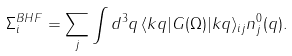<formula> <loc_0><loc_0><loc_500><loc_500>\Sigma _ { i } ^ { B H F } = \sum _ { j } \int d ^ { 3 } q \, \langle k q | G ( \Omega ) | k q \rangle _ { i j } n ^ { 0 } _ { j } ( q ) .</formula> 